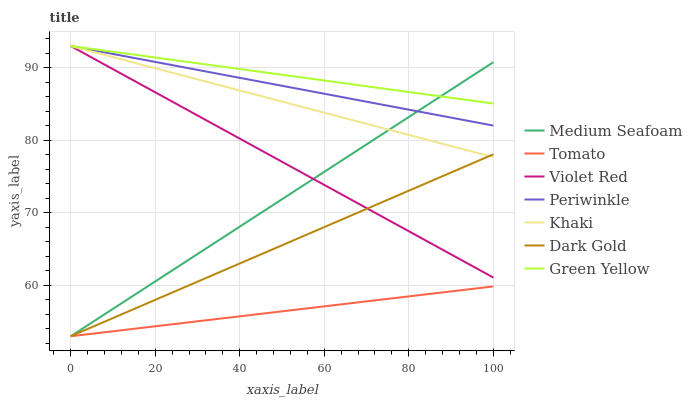Does Tomato have the minimum area under the curve?
Answer yes or no. Yes. Does Green Yellow have the maximum area under the curve?
Answer yes or no. Yes. Does Violet Red have the minimum area under the curve?
Answer yes or no. No. Does Violet Red have the maximum area under the curve?
Answer yes or no. No. Is Dark Gold the smoothest?
Answer yes or no. Yes. Is Green Yellow the roughest?
Answer yes or no. Yes. Is Violet Red the smoothest?
Answer yes or no. No. Is Violet Red the roughest?
Answer yes or no. No. Does Tomato have the lowest value?
Answer yes or no. Yes. Does Violet Red have the lowest value?
Answer yes or no. No. Does Green Yellow have the highest value?
Answer yes or no. Yes. Does Dark Gold have the highest value?
Answer yes or no. No. Is Tomato less than Violet Red?
Answer yes or no. Yes. Is Periwinkle greater than Dark Gold?
Answer yes or no. Yes. Does Green Yellow intersect Violet Red?
Answer yes or no. Yes. Is Green Yellow less than Violet Red?
Answer yes or no. No. Is Green Yellow greater than Violet Red?
Answer yes or no. No. Does Tomato intersect Violet Red?
Answer yes or no. No. 